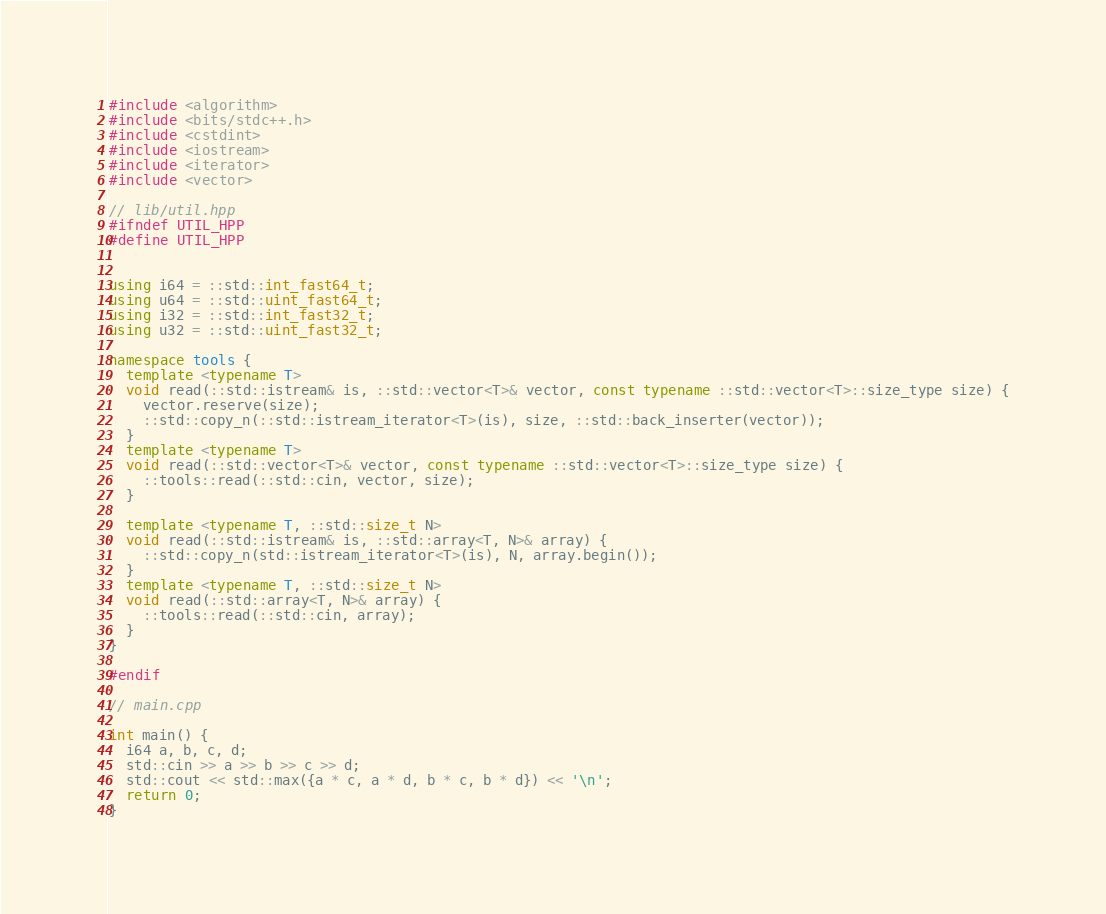Convert code to text. <code><loc_0><loc_0><loc_500><loc_500><_C++_>#include <algorithm>
#include <bits/stdc++.h>
#include <cstdint>
#include <iostream>
#include <iterator>
#include <vector>

// lib/util.hpp
#ifndef UTIL_HPP
#define UTIL_HPP


using i64 = ::std::int_fast64_t;
using u64 = ::std::uint_fast64_t;
using i32 = ::std::int_fast32_t;
using u32 = ::std::uint_fast32_t;

namespace tools {
  template <typename T>
  void read(::std::istream& is, ::std::vector<T>& vector, const typename ::std::vector<T>::size_type size) {
    vector.reserve(size);
    ::std::copy_n(::std::istream_iterator<T>(is), size, ::std::back_inserter(vector));
  }
  template <typename T>
  void read(::std::vector<T>& vector, const typename ::std::vector<T>::size_type size) {
    ::tools::read(::std::cin, vector, size);
  }

  template <typename T, ::std::size_t N>
  void read(::std::istream& is, ::std::array<T, N>& array) {
    ::std::copy_n(std::istream_iterator<T>(is), N, array.begin());
  }
  template <typename T, ::std::size_t N>
  void read(::std::array<T, N>& array) {
    ::tools::read(::std::cin, array);
  }
}

#endif

// main.cpp

int main() {
  i64 a, b, c, d;
  std::cin >> a >> b >> c >> d;
  std::cout << std::max({a * c, a * d, b * c, b * d}) << '\n';
  return 0;
}</code> 